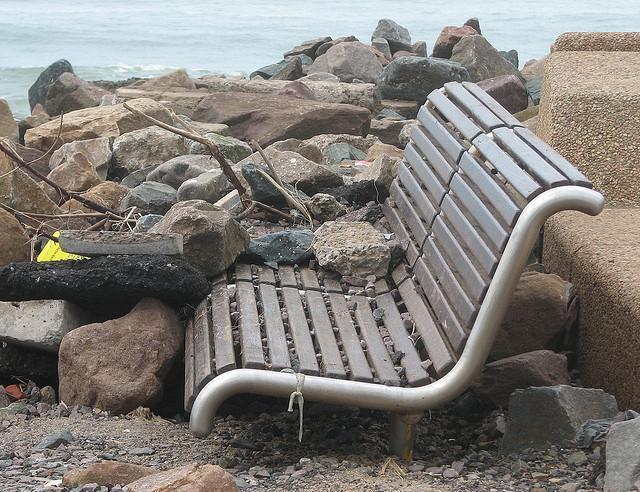How many benches are in the picture?
Give a very brief answer. 1. 